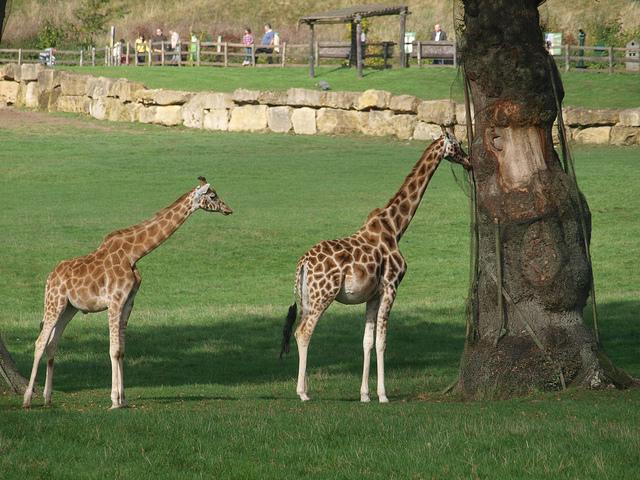What is covering the ground?
Concise answer only. Grass. Is this a zoo?
Quick response, please. Yes. Are these adult giraffes?
Give a very brief answer. No. How many giraffes are there?
Quick response, please. 2. 